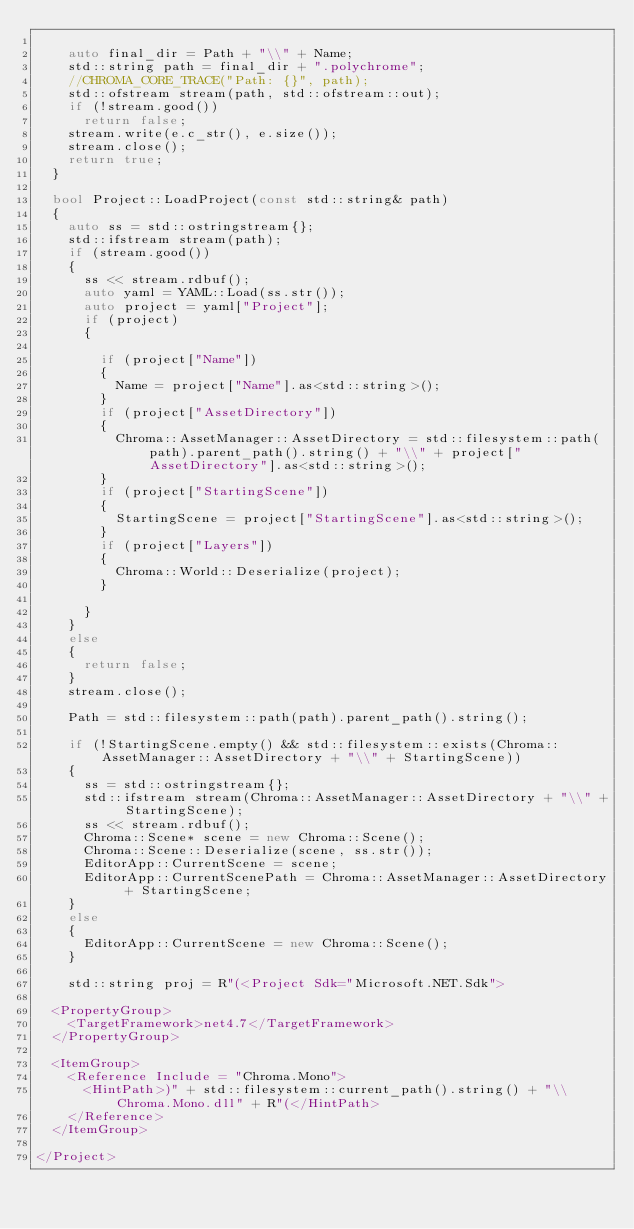Convert code to text. <code><loc_0><loc_0><loc_500><loc_500><_C++_>
		auto final_dir = Path + "\\" + Name;
		std::string path = final_dir + ".polychrome";
		//CHROMA_CORE_TRACE("Path: {}", path);
		std::ofstream stream(path, std::ofstream::out);
		if (!stream.good())
			return false;
		stream.write(e.c_str(), e.size());
		stream.close();
		return true;
	}

	bool Project::LoadProject(const std::string& path)
	{
		auto ss = std::ostringstream{};
		std::ifstream stream(path);
		if (stream.good())
		{
			ss << stream.rdbuf();
			auto yaml = YAML::Load(ss.str());
			auto project = yaml["Project"];
			if (project)
			{

				if (project["Name"])
				{
					Name = project["Name"].as<std::string>();
				}
				if (project["AssetDirectory"])
				{
					Chroma::AssetManager::AssetDirectory = std::filesystem::path(path).parent_path().string() + "\\" + project["AssetDirectory"].as<std::string>();
				}
				if (project["StartingScene"])
				{
					StartingScene = project["StartingScene"].as<std::string>();
				}
				if (project["Layers"])
				{
					Chroma::World::Deserialize(project);
				}

			}
		}
		else
		{
			return false;
		}
		stream.close();

		Path = std::filesystem::path(path).parent_path().string();

		if (!StartingScene.empty() && std::filesystem::exists(Chroma::AssetManager::AssetDirectory + "\\" + StartingScene))
		{
			ss = std::ostringstream{};
			std::ifstream stream(Chroma::AssetManager::AssetDirectory + "\\" + StartingScene);
			ss << stream.rdbuf();
			Chroma::Scene* scene = new Chroma::Scene();
			Chroma::Scene::Deserialize(scene, ss.str());
			EditorApp::CurrentScene = scene;
			EditorApp::CurrentScenePath = Chroma::AssetManager::AssetDirectory + StartingScene;
		}
		else
		{
			EditorApp::CurrentScene = new Chroma::Scene();
		}

		std::string proj = R"(<Project Sdk="Microsoft.NET.Sdk">

	<PropertyGroup>
		<TargetFramework>net4.7</TargetFramework>
	</PropertyGroup>

	<ItemGroup>
		<Reference Include = "Chroma.Mono">
			<HintPath>)" + std::filesystem::current_path().string() + "\\Chroma.Mono.dll" + R"(</HintPath>
		</Reference>
	</ItemGroup>

</Project></code> 